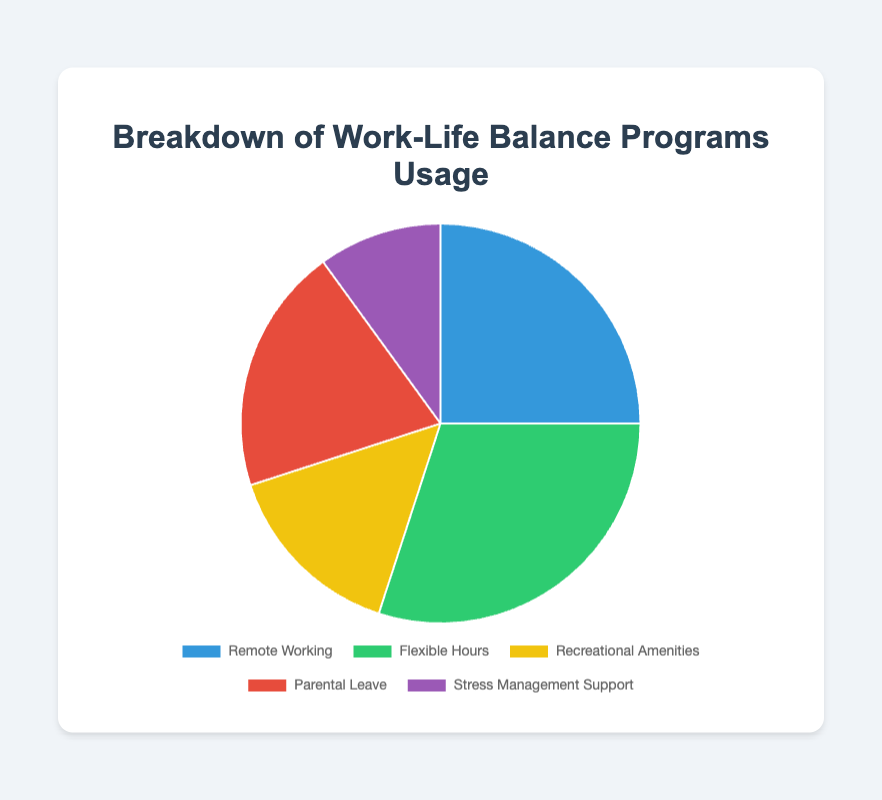Which work-life balance program is most used? The program with the highest percentage is the most used. Flexible Hours has the largest portion at 30%.
Answer: Flexible Hours Which work-life balance program is least used? The program with the lowest percentage is the least used. Stress Management Support has the smallest portion at 10%.
Answer: Stress Management Support What is the combined usage percentage of Remote Working and Parental Leave? Add the percentages of Remote Working (25%) and Parental Leave (20%). 25 + 20 = 45
Answer: 45% How much higher is the usage of Flexible Hours compared to Stress Management Support? Subtract the percentage of Stress Management Support (10%) from that of Flexible Hours (30%). 30 - 10 = 20
Answer: 20% Which programs together account for half of the total usage? Calculate the sum of different combinations to find which ones add up to 50%. Remote Working (25%) and Parental Leave (20%) together with Stress Management Support (10%) sum to 25 + 20 + 10 = 55%, which is closest to 50%.
Answer: Remote Working, Parental Leave, and Stress Management Support Is Recreational Amenities usage more or less than half of Flexible Hours usage? Half of Flexible Hours usage is 30% / 2 = 15%. Recreational Amenities also has 15%, which means it is equal to half of Flexible Hours usage.
Answer: Equal Which segment, representing program usage, is visually the smallest? The segment with the smallest area in the pie chart corresponds to the smallest percentage, which is Stress Management Support at 10%.
Answer: Stress Management Support How does the usage of Parental Leave compare to Recreational Amenities? Compare their percentages. Parental Leave is 20%, while Recreational Amenities is 15%, meaning Parental Leave usage is greater.
Answer: Parental Leave What is the average usage percentage of all the programs? Sum all the percentages and divide by the number of programs. (25 + 30 + 15 + 20 + 10) / 5 = 100 / 5 = 20
Answer: 20% If we combine Recreational Amenities and Stress Management Support, what is their total usage? Add the percentages of Recreational Amenities (15%) and Stress Management Support (10%). 15 + 10 = 25
Answer: 25% 